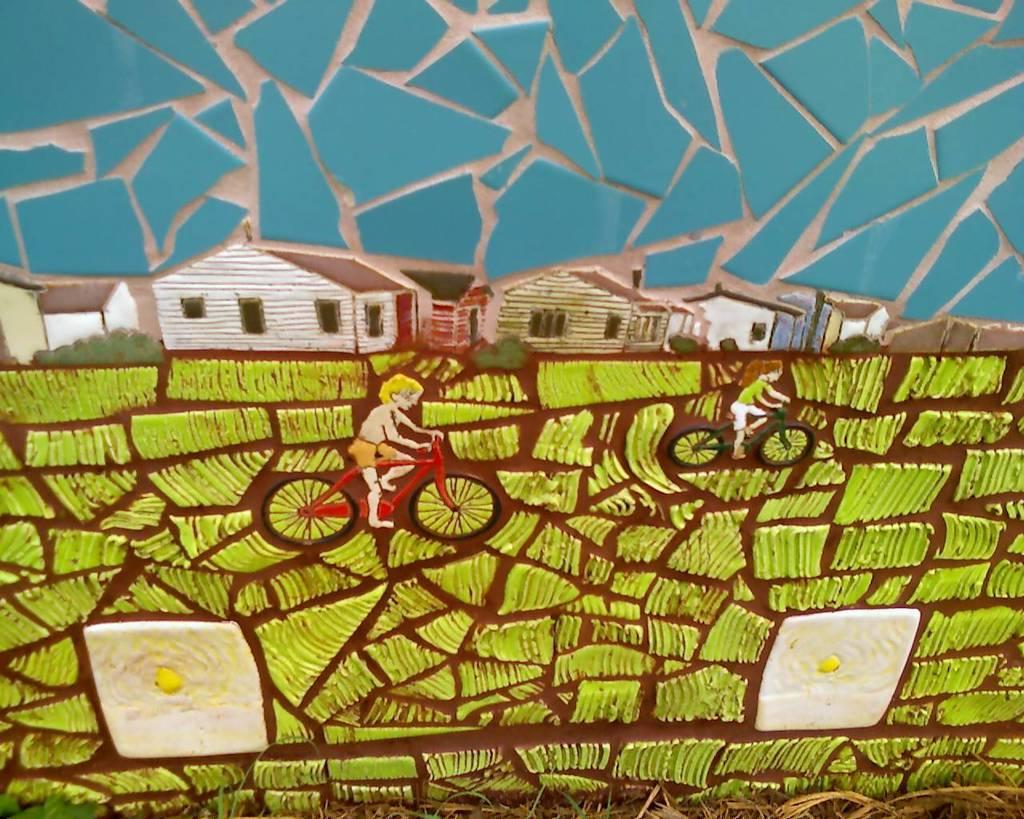Describe this image in one or two sentences. Here we can see an art. These are houses. These two people are sitting on bicycles. 